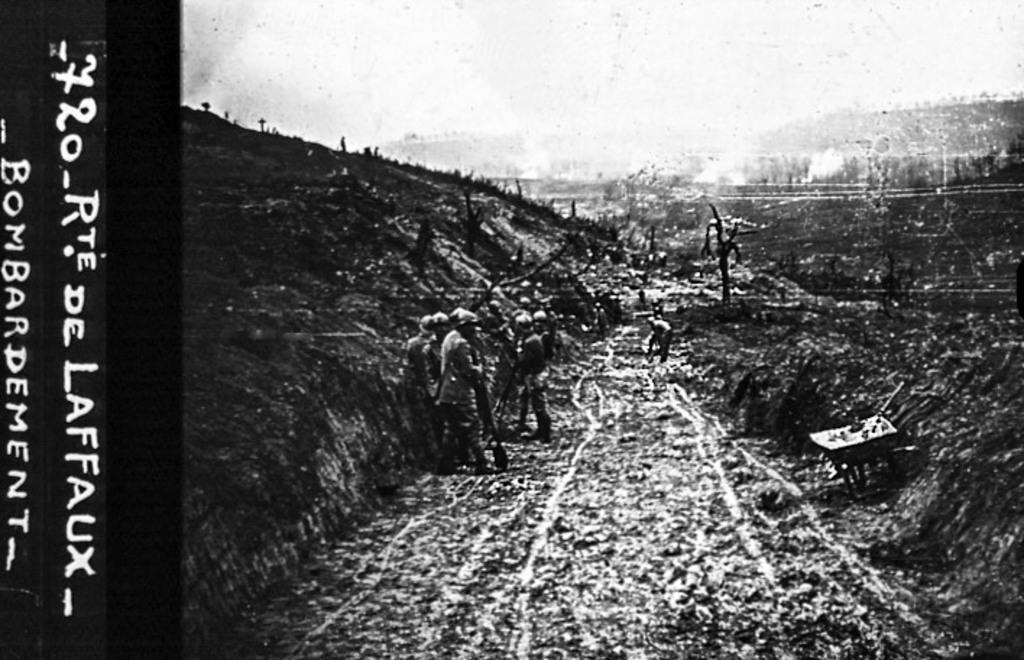<image>
Summarize the visual content of the image. A black and white photograph featuring the bombardment of Rte. de Laffaux. 